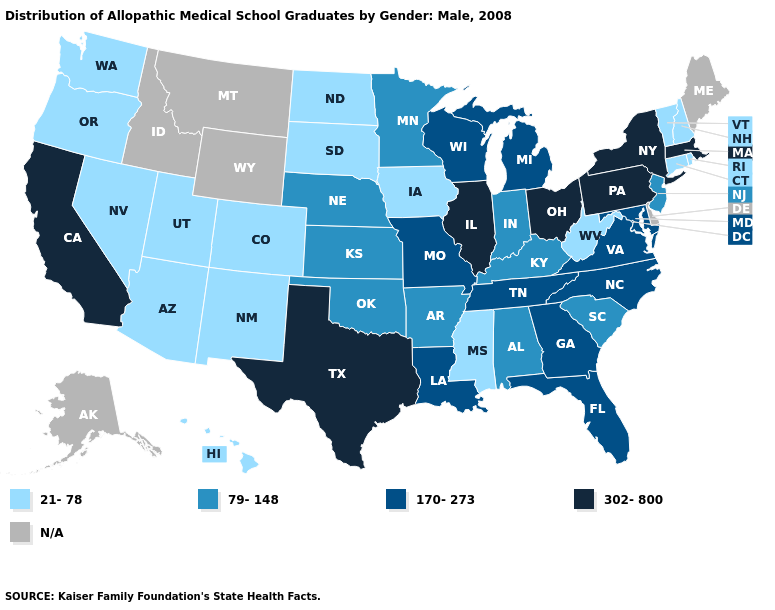Does the map have missing data?
Be succinct. Yes. Among the states that border Tennessee , which have the highest value?
Short answer required. Georgia, Missouri, North Carolina, Virginia. Among the states that border Ohio , does Kentucky have the lowest value?
Quick response, please. No. What is the value of Utah?
Short answer required. 21-78. Name the states that have a value in the range 170-273?
Keep it brief. Florida, Georgia, Louisiana, Maryland, Michigan, Missouri, North Carolina, Tennessee, Virginia, Wisconsin. Does the map have missing data?
Write a very short answer. Yes. Name the states that have a value in the range 302-800?
Be succinct. California, Illinois, Massachusetts, New York, Ohio, Pennsylvania, Texas. Does the first symbol in the legend represent the smallest category?
Quick response, please. Yes. Does North Dakota have the lowest value in the MidWest?
Write a very short answer. Yes. What is the value of Vermont?
Answer briefly. 21-78. What is the value of Washington?
Quick response, please. 21-78. Name the states that have a value in the range 79-148?
Be succinct. Alabama, Arkansas, Indiana, Kansas, Kentucky, Minnesota, Nebraska, New Jersey, Oklahoma, South Carolina. Among the states that border Arizona , which have the highest value?
Write a very short answer. California. 